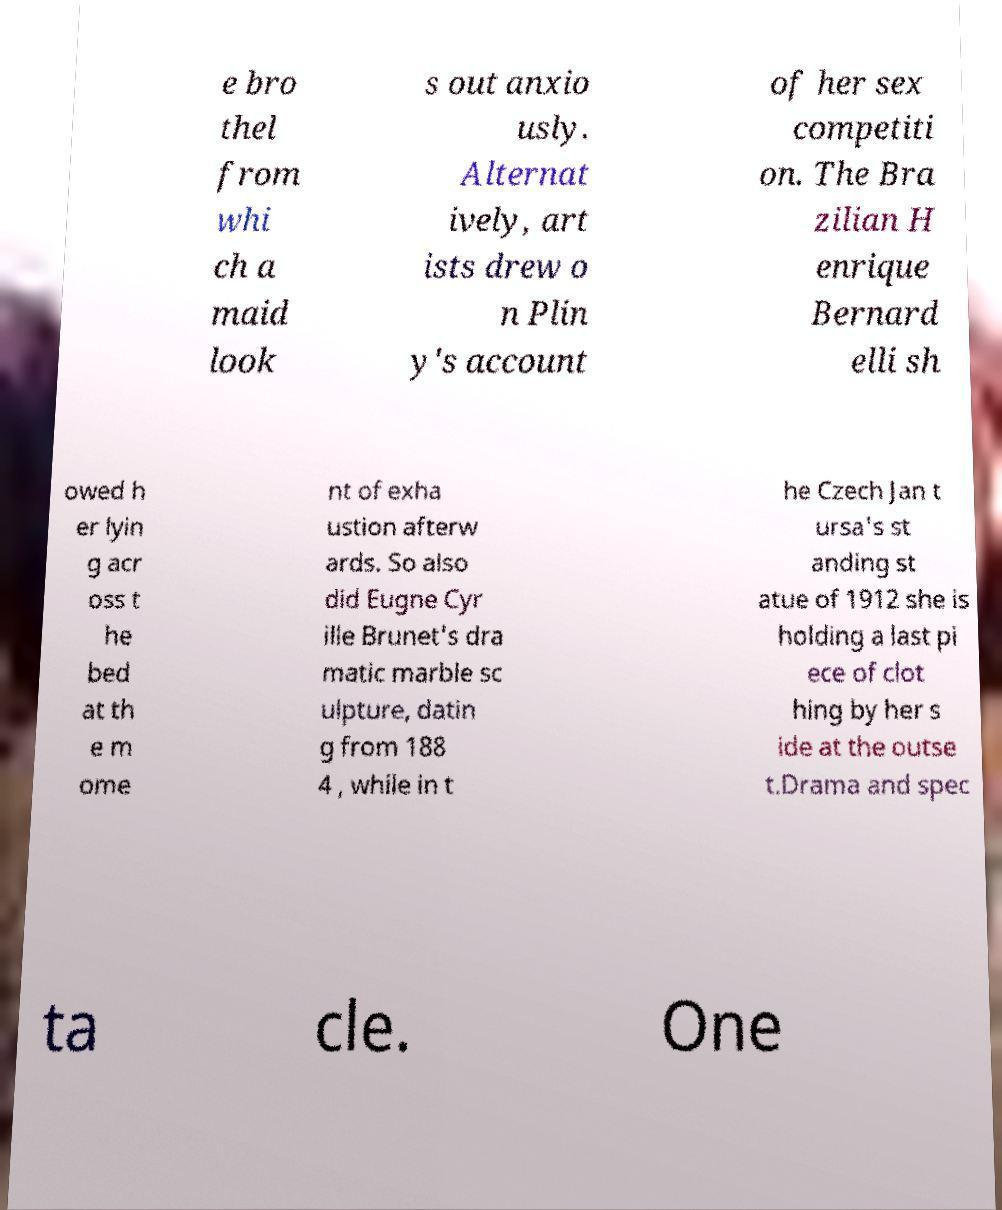Can you read and provide the text displayed in the image?This photo seems to have some interesting text. Can you extract and type it out for me? e bro thel from whi ch a maid look s out anxio usly. Alternat ively, art ists drew o n Plin y's account of her sex competiti on. The Bra zilian H enrique Bernard elli sh owed h er lyin g acr oss t he bed at th e m ome nt of exha ustion afterw ards. So also did Eugne Cyr ille Brunet's dra matic marble sc ulpture, datin g from 188 4 , while in t he Czech Jan t ursa's st anding st atue of 1912 she is holding a last pi ece of clot hing by her s ide at the outse t.Drama and spec ta cle. One 